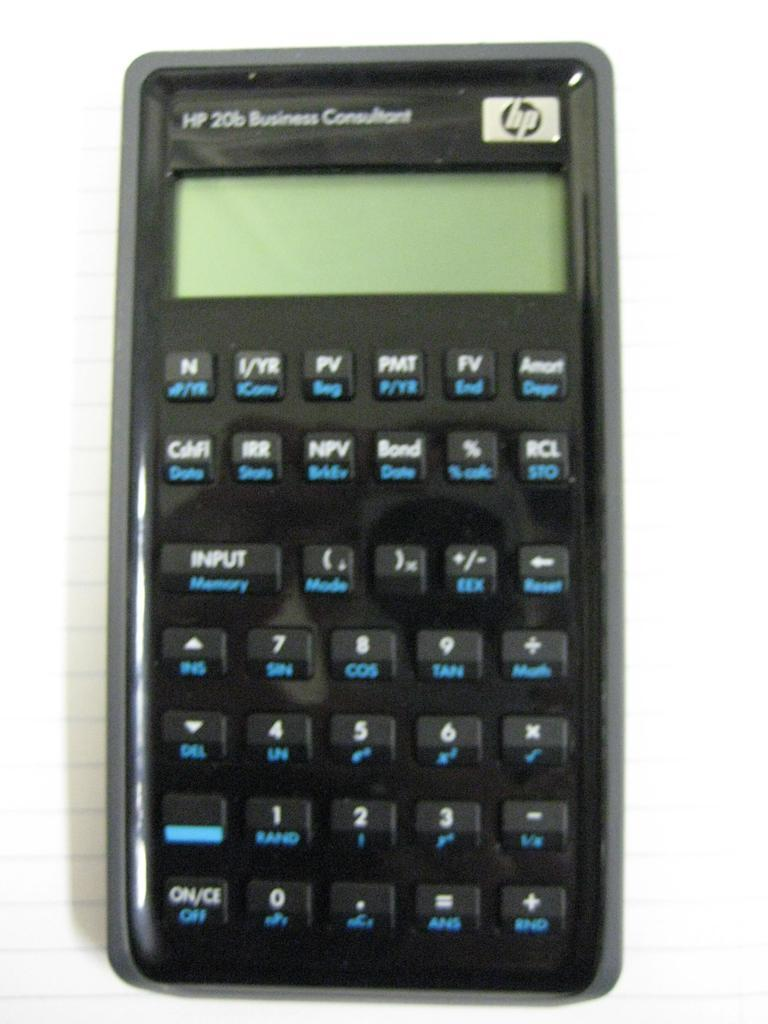<image>
Offer a succinct explanation of the picture presented. An Hp 20b Business Consultant calculator sits on top of a sheet of lined paper. 